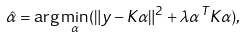<formula> <loc_0><loc_0><loc_500><loc_500>\hat { \alpha } = \arg \min _ { \alpha } ( \| y - K \alpha \| ^ { 2 } + \lambda \alpha ^ { T } K \alpha ) ,</formula> 